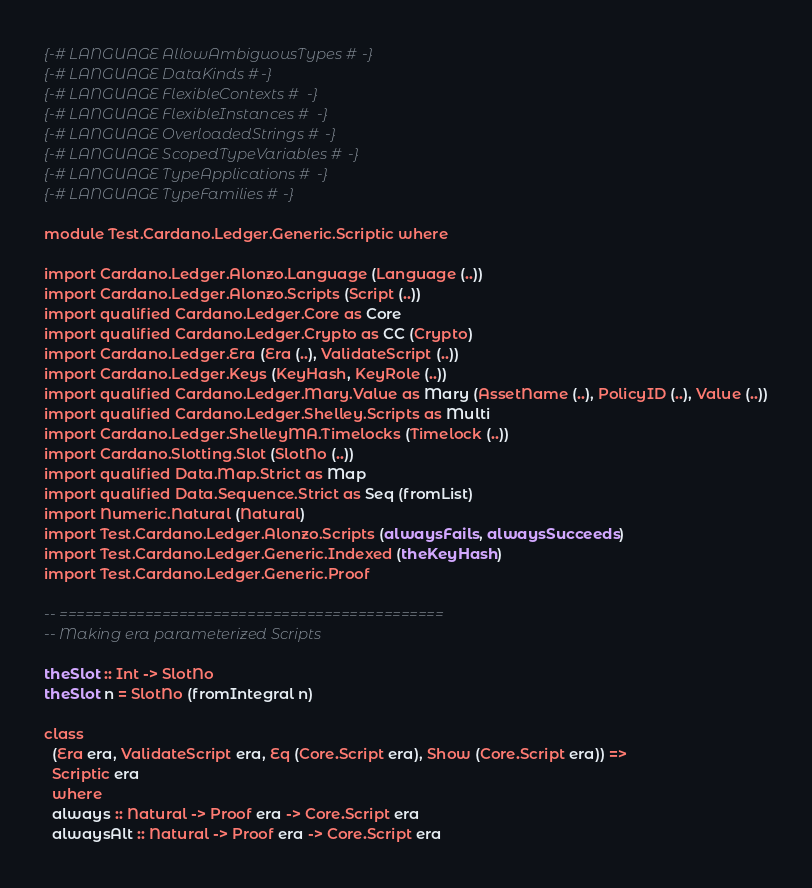<code> <loc_0><loc_0><loc_500><loc_500><_Haskell_>{-# LANGUAGE AllowAmbiguousTypes #-}
{-# LANGUAGE DataKinds #-}
{-# LANGUAGE FlexibleContexts #-}
{-# LANGUAGE FlexibleInstances #-}
{-# LANGUAGE OverloadedStrings #-}
{-# LANGUAGE ScopedTypeVariables #-}
{-# LANGUAGE TypeApplications #-}
{-# LANGUAGE TypeFamilies #-}

module Test.Cardano.Ledger.Generic.Scriptic where

import Cardano.Ledger.Alonzo.Language (Language (..))
import Cardano.Ledger.Alonzo.Scripts (Script (..))
import qualified Cardano.Ledger.Core as Core
import qualified Cardano.Ledger.Crypto as CC (Crypto)
import Cardano.Ledger.Era (Era (..), ValidateScript (..))
import Cardano.Ledger.Keys (KeyHash, KeyRole (..))
import qualified Cardano.Ledger.Mary.Value as Mary (AssetName (..), PolicyID (..), Value (..))
import qualified Cardano.Ledger.Shelley.Scripts as Multi
import Cardano.Ledger.ShelleyMA.Timelocks (Timelock (..))
import Cardano.Slotting.Slot (SlotNo (..))
import qualified Data.Map.Strict as Map
import qualified Data.Sequence.Strict as Seq (fromList)
import Numeric.Natural (Natural)
import Test.Cardano.Ledger.Alonzo.Scripts (alwaysFails, alwaysSucceeds)
import Test.Cardano.Ledger.Generic.Indexed (theKeyHash)
import Test.Cardano.Ledger.Generic.Proof

-- =============================================
-- Making era parameterized Scripts

theSlot :: Int -> SlotNo
theSlot n = SlotNo (fromIntegral n)

class
  (Era era, ValidateScript era, Eq (Core.Script era), Show (Core.Script era)) =>
  Scriptic era
  where
  always :: Natural -> Proof era -> Core.Script era
  alwaysAlt :: Natural -> Proof era -> Core.Script era</code> 